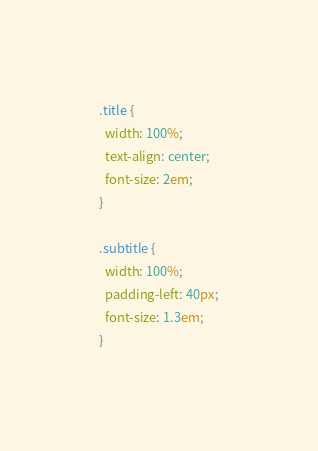<code> <loc_0><loc_0><loc_500><loc_500><_CSS_>.title {
  width: 100%;
  text-align: center;
  font-size: 2em;
}

.subtitle {
  width: 100%;
  padding-left: 40px;
  font-size: 1.3em;
}</code> 